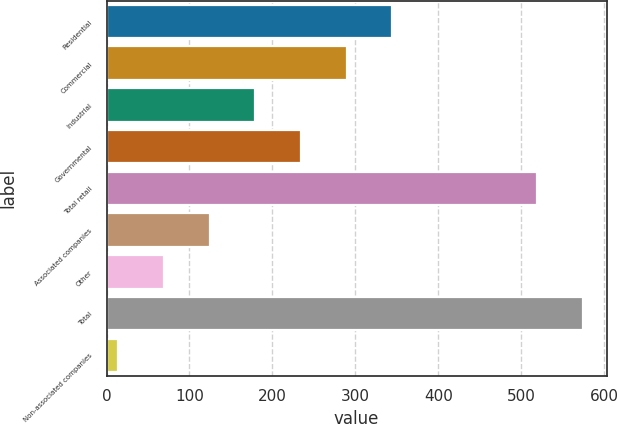<chart> <loc_0><loc_0><loc_500><loc_500><bar_chart><fcel>Residential<fcel>Commercial<fcel>Industrial<fcel>Governmental<fcel>Total retail<fcel>Associated companies<fcel>Other<fcel>Total<fcel>Non-associated companies<nl><fcel>344.6<fcel>289.5<fcel>179.3<fcel>234.4<fcel>519<fcel>124.2<fcel>69.1<fcel>574.1<fcel>14<nl></chart> 